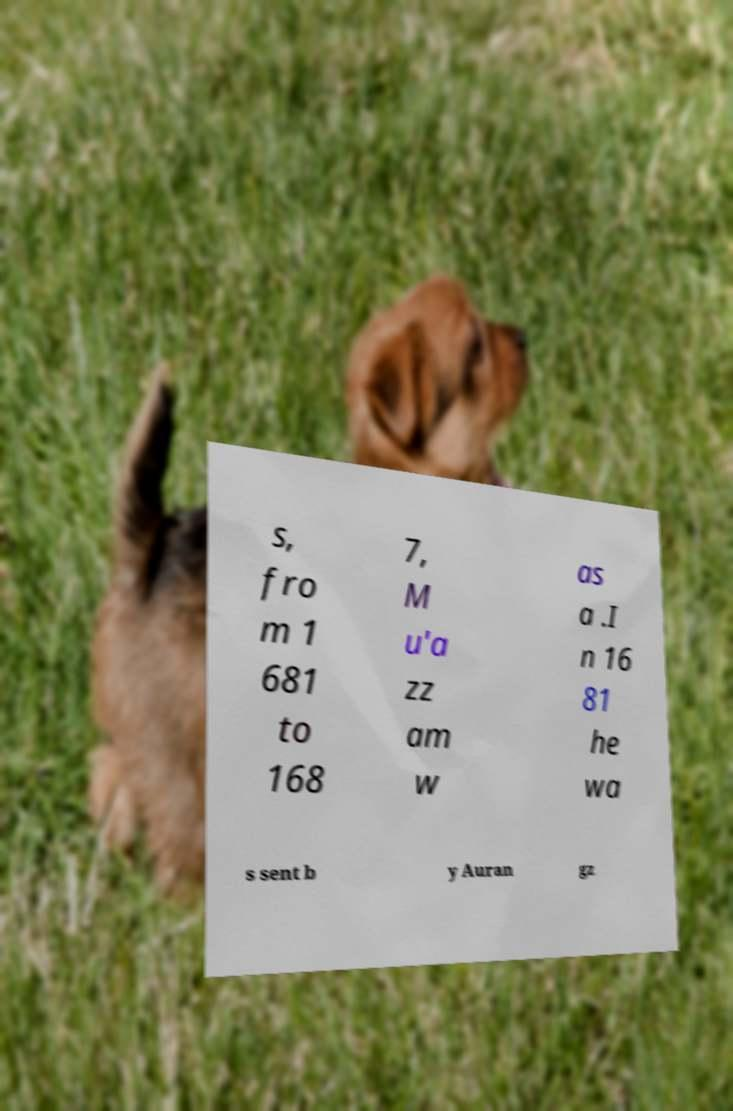Could you assist in decoding the text presented in this image and type it out clearly? s, fro m 1 681 to 168 7, M u'a zz am w as a .I n 16 81 he wa s sent b y Auran gz 